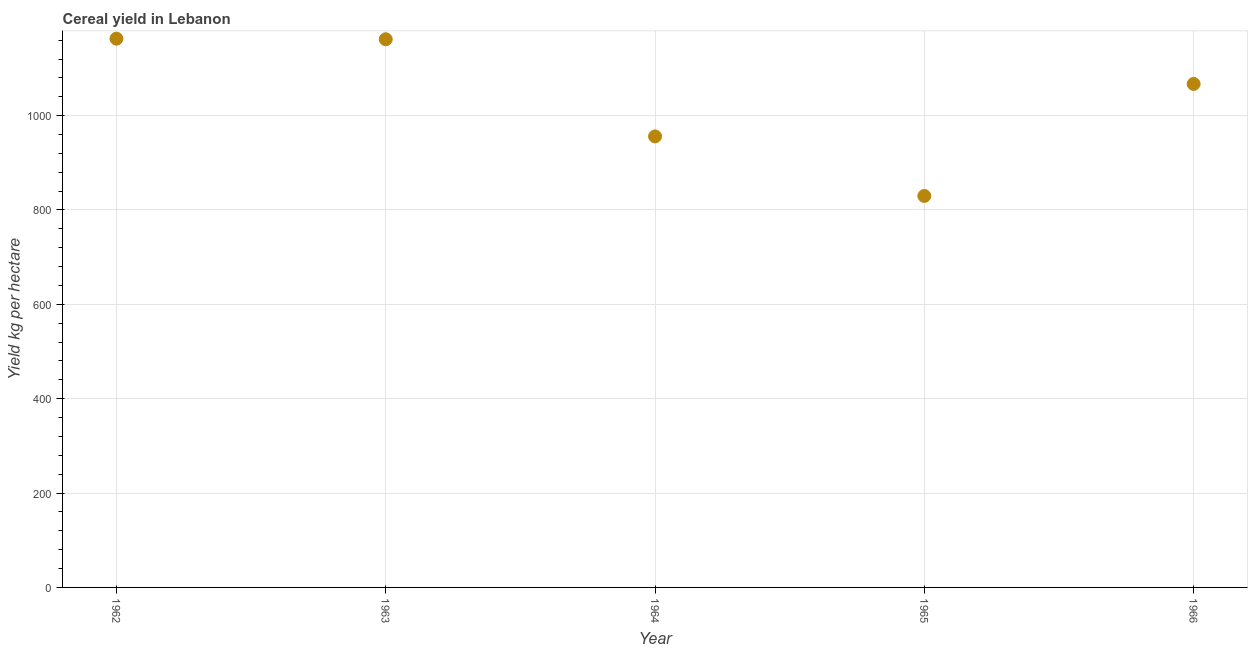What is the cereal yield in 1964?
Your response must be concise. 955.96. Across all years, what is the maximum cereal yield?
Ensure brevity in your answer.  1163.09. Across all years, what is the minimum cereal yield?
Provide a short and direct response. 829.79. In which year was the cereal yield maximum?
Provide a short and direct response. 1962. In which year was the cereal yield minimum?
Ensure brevity in your answer.  1965. What is the sum of the cereal yield?
Provide a short and direct response. 5177.92. What is the difference between the cereal yield in 1963 and 1966?
Ensure brevity in your answer.  94.65. What is the average cereal yield per year?
Your answer should be compact. 1035.58. What is the median cereal yield?
Offer a terse response. 1067.21. Do a majority of the years between 1963 and 1966 (inclusive) have cereal yield greater than 40 kg per hectare?
Make the answer very short. Yes. What is the ratio of the cereal yield in 1963 to that in 1965?
Keep it short and to the point. 1.4. Is the cereal yield in 1962 less than that in 1964?
Give a very brief answer. No. What is the difference between the highest and the second highest cereal yield?
Provide a short and direct response. 1.22. Is the sum of the cereal yield in 1963 and 1966 greater than the maximum cereal yield across all years?
Provide a short and direct response. Yes. What is the difference between the highest and the lowest cereal yield?
Provide a succinct answer. 333.29. In how many years, is the cereal yield greater than the average cereal yield taken over all years?
Give a very brief answer. 3. Does the cereal yield monotonically increase over the years?
Offer a very short reply. No. What is the difference between two consecutive major ticks on the Y-axis?
Keep it short and to the point. 200. Are the values on the major ticks of Y-axis written in scientific E-notation?
Your response must be concise. No. Does the graph contain any zero values?
Provide a short and direct response. No. Does the graph contain grids?
Offer a very short reply. Yes. What is the title of the graph?
Offer a very short reply. Cereal yield in Lebanon. What is the label or title of the X-axis?
Provide a short and direct response. Year. What is the label or title of the Y-axis?
Your response must be concise. Yield kg per hectare. What is the Yield kg per hectare in 1962?
Give a very brief answer. 1163.09. What is the Yield kg per hectare in 1963?
Your response must be concise. 1161.87. What is the Yield kg per hectare in 1964?
Make the answer very short. 955.96. What is the Yield kg per hectare in 1965?
Provide a short and direct response. 829.79. What is the Yield kg per hectare in 1966?
Your answer should be very brief. 1067.21. What is the difference between the Yield kg per hectare in 1962 and 1963?
Keep it short and to the point. 1.22. What is the difference between the Yield kg per hectare in 1962 and 1964?
Your answer should be compact. 207.13. What is the difference between the Yield kg per hectare in 1962 and 1965?
Keep it short and to the point. 333.29. What is the difference between the Yield kg per hectare in 1962 and 1966?
Offer a very short reply. 95.88. What is the difference between the Yield kg per hectare in 1963 and 1964?
Your response must be concise. 205.91. What is the difference between the Yield kg per hectare in 1963 and 1965?
Ensure brevity in your answer.  332.07. What is the difference between the Yield kg per hectare in 1963 and 1966?
Give a very brief answer. 94.65. What is the difference between the Yield kg per hectare in 1964 and 1965?
Keep it short and to the point. 126.17. What is the difference between the Yield kg per hectare in 1964 and 1966?
Offer a terse response. -111.25. What is the difference between the Yield kg per hectare in 1965 and 1966?
Make the answer very short. -237.42. What is the ratio of the Yield kg per hectare in 1962 to that in 1963?
Your answer should be compact. 1. What is the ratio of the Yield kg per hectare in 1962 to that in 1964?
Your response must be concise. 1.22. What is the ratio of the Yield kg per hectare in 1962 to that in 1965?
Provide a short and direct response. 1.4. What is the ratio of the Yield kg per hectare in 1962 to that in 1966?
Your answer should be compact. 1.09. What is the ratio of the Yield kg per hectare in 1963 to that in 1964?
Keep it short and to the point. 1.22. What is the ratio of the Yield kg per hectare in 1963 to that in 1965?
Your response must be concise. 1.4. What is the ratio of the Yield kg per hectare in 1963 to that in 1966?
Offer a very short reply. 1.09. What is the ratio of the Yield kg per hectare in 1964 to that in 1965?
Your response must be concise. 1.15. What is the ratio of the Yield kg per hectare in 1964 to that in 1966?
Provide a succinct answer. 0.9. What is the ratio of the Yield kg per hectare in 1965 to that in 1966?
Your response must be concise. 0.78. 